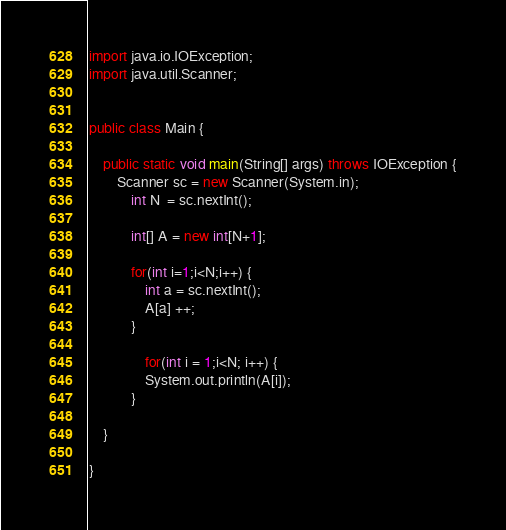Convert code to text. <code><loc_0><loc_0><loc_500><loc_500><_Java_>import java.io.IOException;
import java.util.Scanner;


public class Main {

	public static void main(String[] args) throws IOException {
		Scanner sc = new Scanner(System.in);
			int N  = sc.nextInt();

			int[] A = new int[N+1];

			for(int i=1;i<N;i++) {
				int a = sc.nextInt();
				A[a] ++;
			}

				for(int i = 1;i<N; i++) {
				System.out.println(A[i]);
			}

	}

}
</code> 